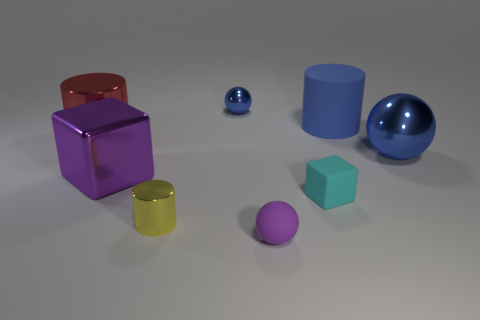Add 1 yellow metallic cylinders. How many objects exist? 9 Subtract all tiny balls. How many balls are left? 1 Subtract all blue cylinders. How many blue spheres are left? 2 Subtract 1 spheres. How many spheres are left? 2 Subtract all cubes. How many objects are left? 6 Subtract all things. Subtract all small green rubber blocks. How many objects are left? 0 Add 3 cyan rubber objects. How many cyan rubber objects are left? 4 Add 6 red cylinders. How many red cylinders exist? 7 Subtract 0 brown cylinders. How many objects are left? 8 